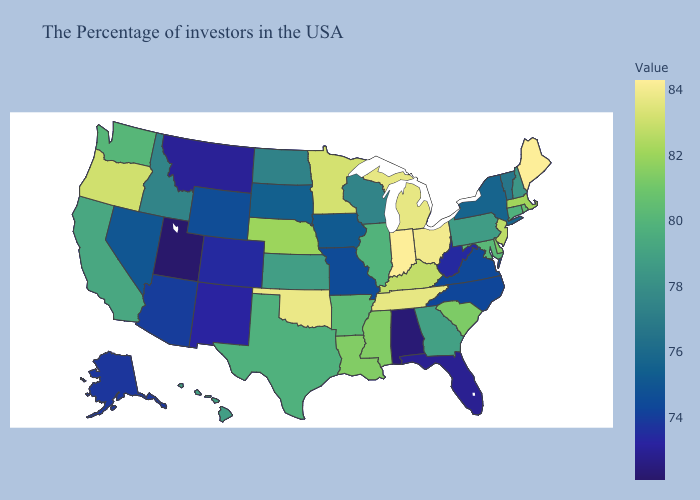Among the states that border Missouri , does Kentucky have the highest value?
Quick response, please. No. Which states have the lowest value in the USA?
Quick response, please. Utah. Does West Virginia have the lowest value in the South?
Write a very short answer. No. Which states have the lowest value in the MidWest?
Keep it brief. Missouri. Does Maine have the highest value in the USA?
Short answer required. Yes. Does West Virginia have the highest value in the USA?
Short answer required. No. Does New Hampshire have a lower value than Vermont?
Short answer required. No. Which states hav the highest value in the Northeast?
Write a very short answer. Maine. Among the states that border Tennessee , does Alabama have the lowest value?
Short answer required. Yes. 